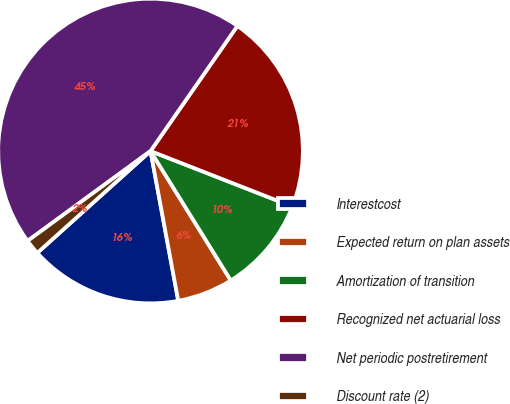Convert chart. <chart><loc_0><loc_0><loc_500><loc_500><pie_chart><fcel>Interestcost<fcel>Expected return on plan assets<fcel>Amortization of transition<fcel>Recognized net actuarial loss<fcel>Net periodic postretirement<fcel>Discount rate (2)<nl><fcel>16.25%<fcel>5.92%<fcel>10.23%<fcel>21.27%<fcel>44.7%<fcel>1.61%<nl></chart> 